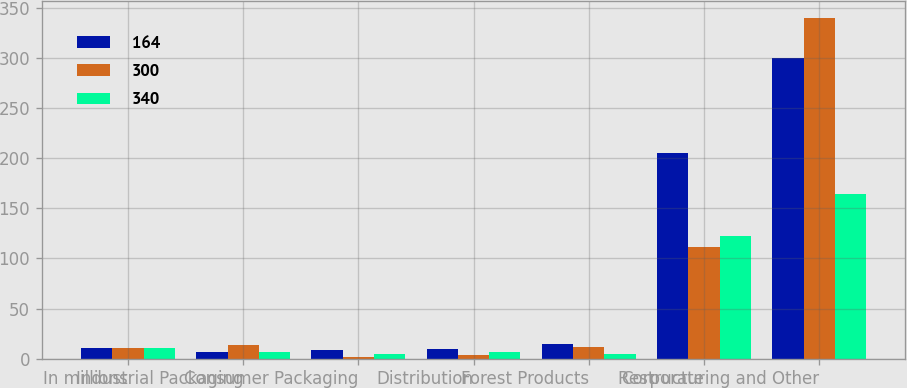Convert chart to OTSL. <chart><loc_0><loc_0><loc_500><loc_500><stacked_bar_chart><ecel><fcel>In millions<fcel>Industrial Packaging<fcel>Consumer Packaging<fcel>Distribution<fcel>Forest Products<fcel>Corporate<fcel>Restructuring and Other<nl><fcel>164<fcel>11<fcel>7<fcel>9<fcel>10<fcel>15<fcel>205<fcel>300<nl><fcel>300<fcel>11<fcel>14<fcel>2<fcel>4<fcel>12<fcel>111<fcel>340<nl><fcel>340<fcel>11<fcel>7<fcel>5<fcel>7<fcel>5<fcel>122<fcel>164<nl></chart> 